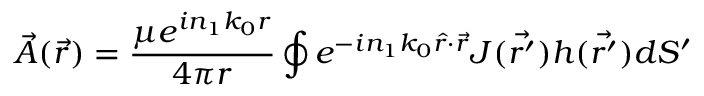<formula> <loc_0><loc_0><loc_500><loc_500>\vec { A } ( \vec { r } ) = \frac { \mu e ^ { i n _ { 1 } k _ { 0 } r } } { 4 \pi r } \oint e ^ { - i n _ { 1 } k _ { 0 } \hat { r } \cdot \vec { r } } J ( \vec { r ^ { \prime } } ) h ( \vec { r ^ { \prime } } ) d S ^ { \prime }</formula> 